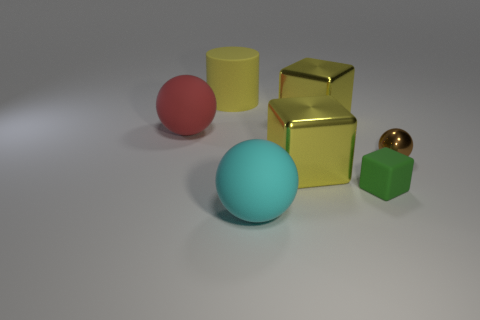Does the brown sphere have the same material as the big sphere that is on the left side of the big yellow rubber cylinder?
Your answer should be very brief. No. What number of things are big matte things that are to the left of the yellow cylinder or big cyan matte things?
Your answer should be compact. 2. What is the size of the matte object that is in front of the matte object right of the ball that is in front of the tiny brown thing?
Offer a very short reply. Large. Are there any other things that have the same shape as the red thing?
Keep it short and to the point. Yes. What is the size of the yellow thing in front of the yellow metallic object behind the brown object?
Offer a terse response. Large. What number of small things are brown balls or green cubes?
Your response must be concise. 2. Are there fewer green rubber cubes than cubes?
Ensure brevity in your answer.  Yes. Are there any other things that are the same size as the matte cube?
Your answer should be compact. Yes. Do the small sphere and the large cylinder have the same color?
Give a very brief answer. No. Is the number of large yellow cubes greater than the number of large blue rubber cylinders?
Your answer should be compact. Yes. 